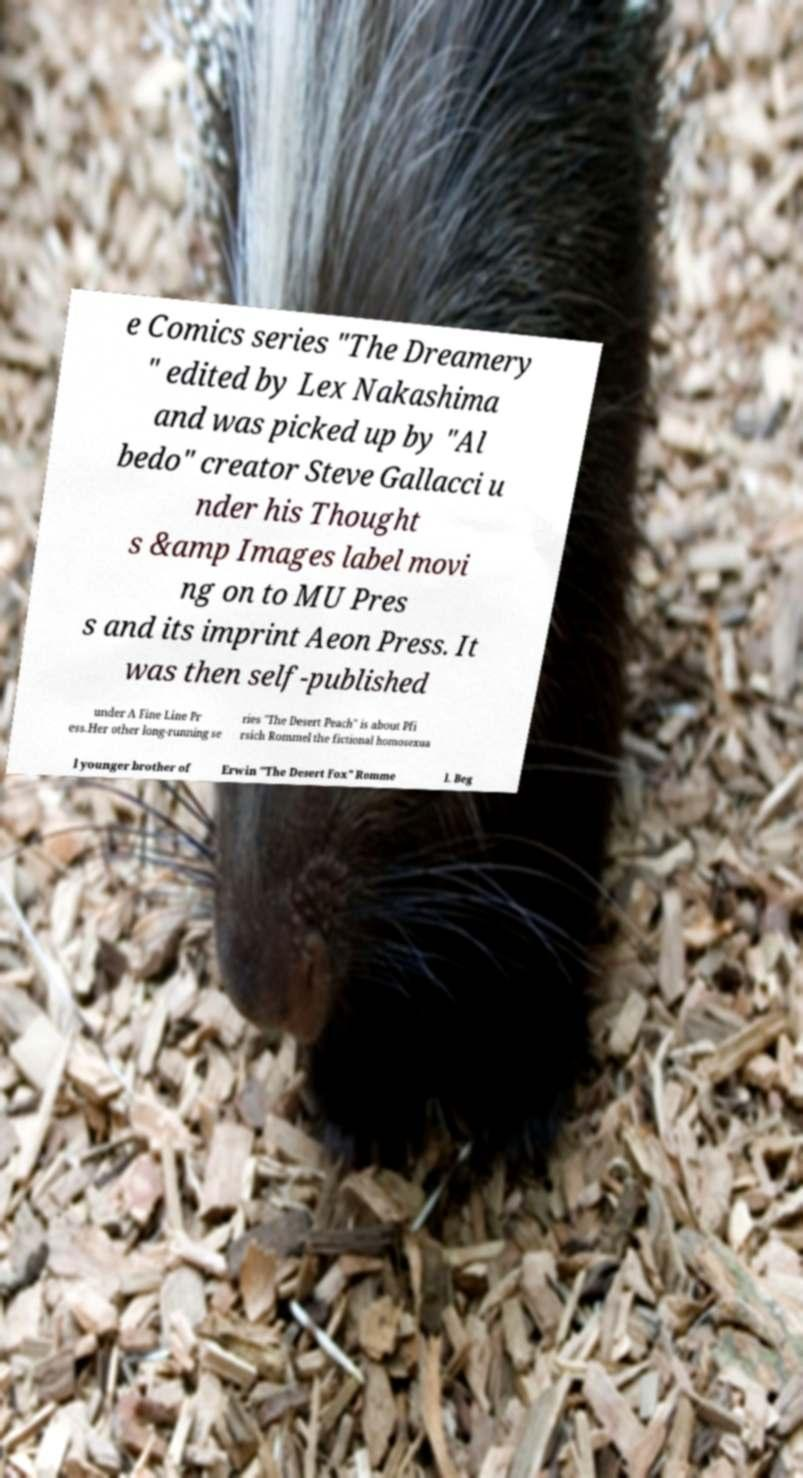Can you read and provide the text displayed in the image?This photo seems to have some interesting text. Can you extract and type it out for me? e Comics series "The Dreamery " edited by Lex Nakashima and was picked up by "Al bedo" creator Steve Gallacci u nder his Thought s &amp Images label movi ng on to MU Pres s and its imprint Aeon Press. It was then self-published under A Fine Line Pr ess.Her other long-running se ries "The Desert Peach" is about Pfi rsich Rommel the fictional homosexua l younger brother of Erwin "The Desert Fox" Romme l. Beg 